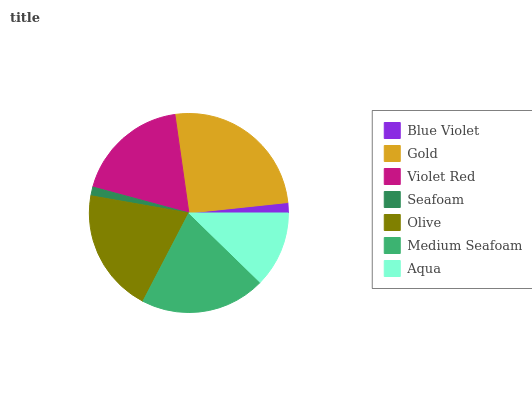Is Seafoam the minimum?
Answer yes or no. Yes. Is Gold the maximum?
Answer yes or no. Yes. Is Violet Red the minimum?
Answer yes or no. No. Is Violet Red the maximum?
Answer yes or no. No. Is Gold greater than Violet Red?
Answer yes or no. Yes. Is Violet Red less than Gold?
Answer yes or no. Yes. Is Violet Red greater than Gold?
Answer yes or no. No. Is Gold less than Violet Red?
Answer yes or no. No. Is Violet Red the high median?
Answer yes or no. Yes. Is Violet Red the low median?
Answer yes or no. Yes. Is Olive the high median?
Answer yes or no. No. Is Blue Violet the low median?
Answer yes or no. No. 